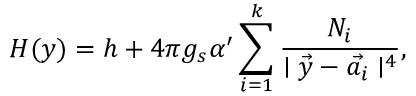Convert formula to latex. <formula><loc_0><loc_0><loc_500><loc_500>H ( y ) = h + 4 \pi g _ { s } \alpha ^ { \prime } \sum _ { i = 1 } ^ { k } \frac { N _ { i } } { | \vec { y } - \vec { a _ { i } } | ^ { 4 } } ,</formula> 